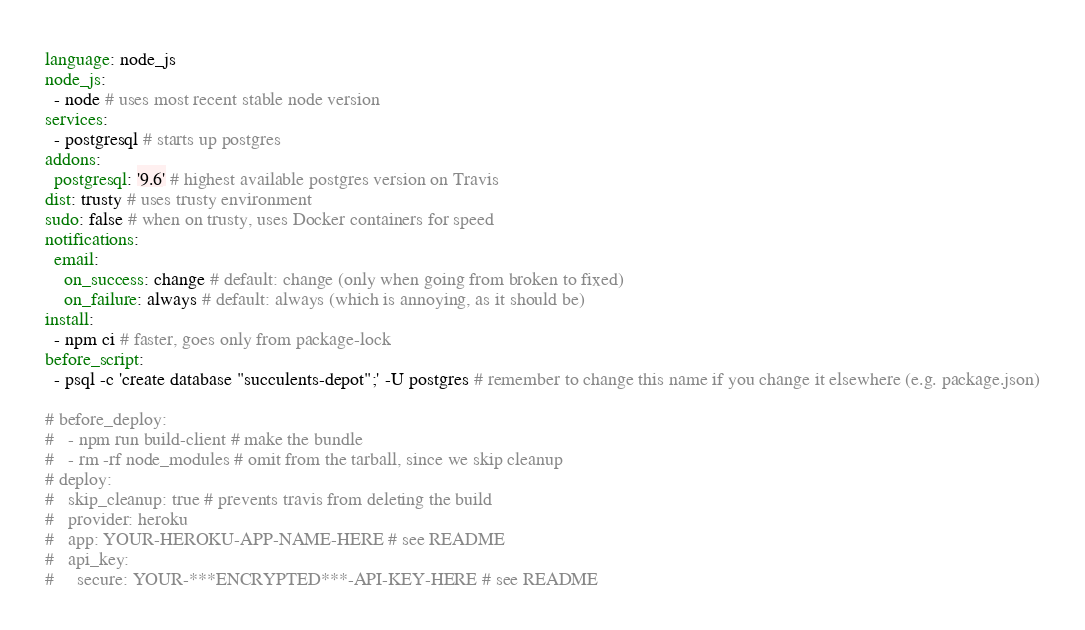Convert code to text. <code><loc_0><loc_0><loc_500><loc_500><_YAML_>language: node_js
node_js:
  - node # uses most recent stable node version
services:
  - postgresql # starts up postgres
addons:
  postgresql: '9.6' # highest available postgres version on Travis
dist: trusty # uses trusty environment
sudo: false # when on trusty, uses Docker containers for speed
notifications:
  email:
    on_success: change # default: change (only when going from broken to fixed)
    on_failure: always # default: always (which is annoying, as it should be)
install:
  - npm ci # faster, goes only from package-lock
before_script:
  - psql -c 'create database "succulents-depot";' -U postgres # remember to change this name if you change it elsewhere (e.g. package.json)

# before_deploy:
#   - npm run build-client # make the bundle
#   - rm -rf node_modules # omit from the tarball, since we skip cleanup
# deploy:
#   skip_cleanup: true # prevents travis from deleting the build
#   provider: heroku
#   app: YOUR-HEROKU-APP-NAME-HERE # see README
#   api_key:
#     secure: YOUR-***ENCRYPTED***-API-KEY-HERE # see README
</code> 